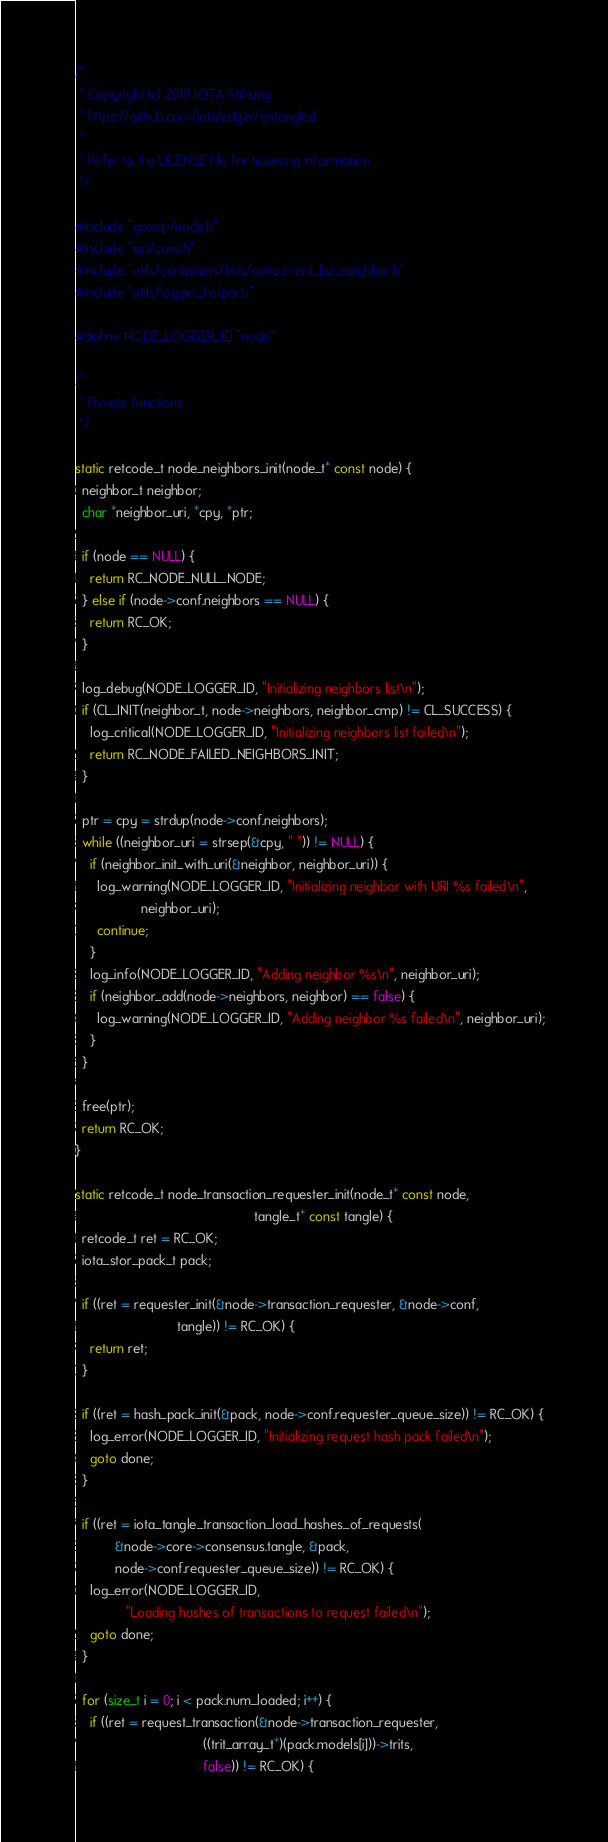<code> <loc_0><loc_0><loc_500><loc_500><_C_>/*
 * Copyright (c) 2018 IOTA Stiftung
 * https://github.com/iotaledger/entangled
 *
 * Refer to the LICENSE file for licensing information
 */

#include "gossip/node.h"
#include "ciri/core.h"
#include "utils/containers/lists/concurrent_list_neighbor.h"
#include "utils/logger_helper.h"

#define NODE_LOGGER_ID "node"

/*
 * Private functions
 */

static retcode_t node_neighbors_init(node_t* const node) {
  neighbor_t neighbor;
  char *neighbor_uri, *cpy, *ptr;

  if (node == NULL) {
    return RC_NODE_NULL_NODE;
  } else if (node->conf.neighbors == NULL) {
    return RC_OK;
  }

  log_debug(NODE_LOGGER_ID, "Initializing neighbors list\n");
  if (CL_INIT(neighbor_t, node->neighbors, neighbor_cmp) != CL_SUCCESS) {
    log_critical(NODE_LOGGER_ID, "Initializing neighbors list failed\n");
    return RC_NODE_FAILED_NEIGHBORS_INIT;
  }

  ptr = cpy = strdup(node->conf.neighbors);
  while ((neighbor_uri = strsep(&cpy, " ")) != NULL) {
    if (neighbor_init_with_uri(&neighbor, neighbor_uri)) {
      log_warning(NODE_LOGGER_ID, "Initializing neighbor with URI %s failed\n",
                  neighbor_uri);
      continue;
    }
    log_info(NODE_LOGGER_ID, "Adding neighbor %s\n", neighbor_uri);
    if (neighbor_add(node->neighbors, neighbor) == false) {
      log_warning(NODE_LOGGER_ID, "Adding neighbor %s failed\n", neighbor_uri);
    }
  }

  free(ptr);
  return RC_OK;
}

static retcode_t node_transaction_requester_init(node_t* const node,
                                                 tangle_t* const tangle) {
  retcode_t ret = RC_OK;
  iota_stor_pack_t pack;

  if ((ret = requester_init(&node->transaction_requester, &node->conf,
                            tangle)) != RC_OK) {
    return ret;
  }

  if ((ret = hash_pack_init(&pack, node->conf.requester_queue_size)) != RC_OK) {
    log_error(NODE_LOGGER_ID, "Initializing request hash pack failed\n");
    goto done;
  }

  if ((ret = iota_tangle_transaction_load_hashes_of_requests(
           &node->core->consensus.tangle, &pack,
           node->conf.requester_queue_size)) != RC_OK) {
    log_error(NODE_LOGGER_ID,
              "Loading hashes of transactions to request failed\n");
    goto done;
  }

  for (size_t i = 0; i < pack.num_loaded; i++) {
    if ((ret = request_transaction(&node->transaction_requester,
                                   ((trit_array_t*)(pack.models[i]))->trits,
                                   false)) != RC_OK) {</code> 